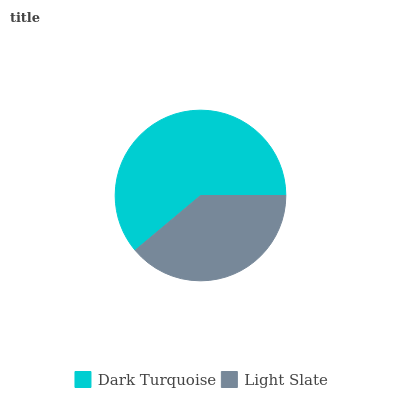Is Light Slate the minimum?
Answer yes or no. Yes. Is Dark Turquoise the maximum?
Answer yes or no. Yes. Is Light Slate the maximum?
Answer yes or no. No. Is Dark Turquoise greater than Light Slate?
Answer yes or no. Yes. Is Light Slate less than Dark Turquoise?
Answer yes or no. Yes. Is Light Slate greater than Dark Turquoise?
Answer yes or no. No. Is Dark Turquoise less than Light Slate?
Answer yes or no. No. Is Dark Turquoise the high median?
Answer yes or no. Yes. Is Light Slate the low median?
Answer yes or no. Yes. Is Light Slate the high median?
Answer yes or no. No. Is Dark Turquoise the low median?
Answer yes or no. No. 